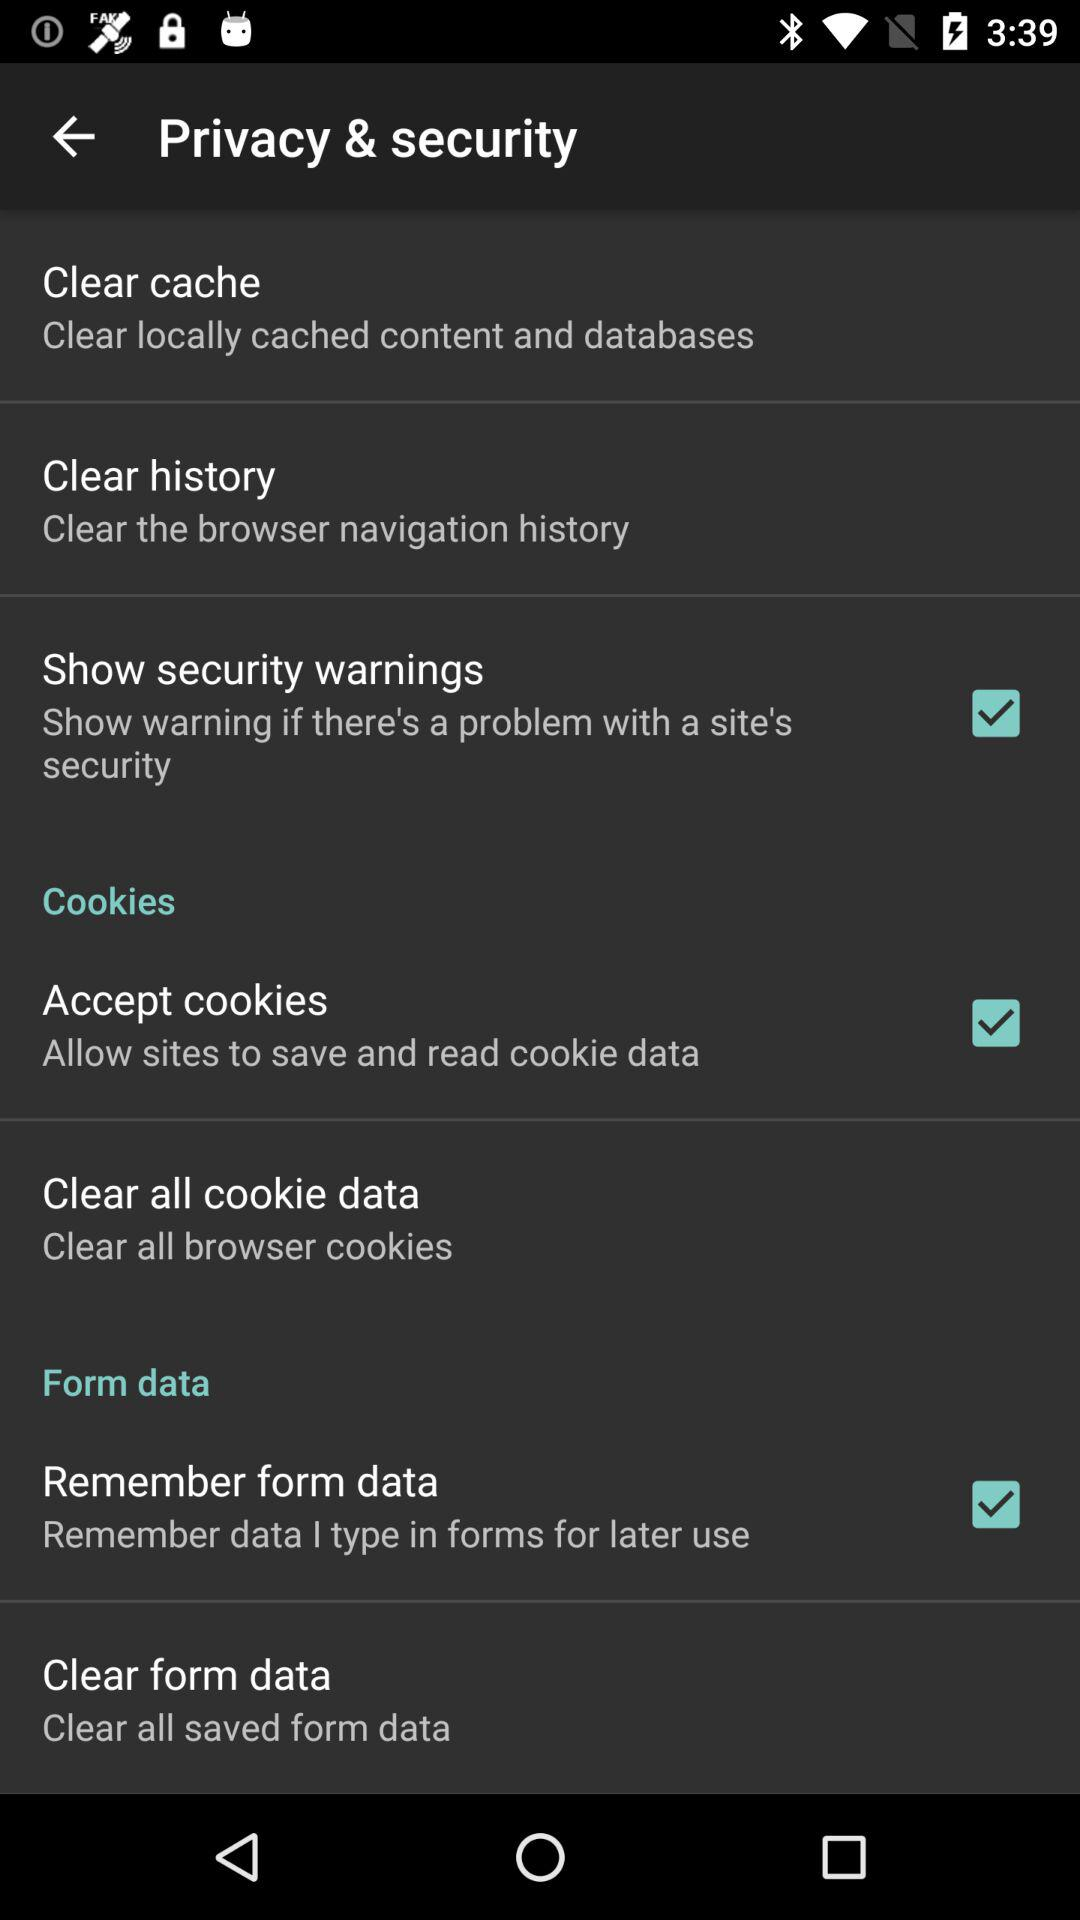What is the status of "Remember form data"? The status is "on". 